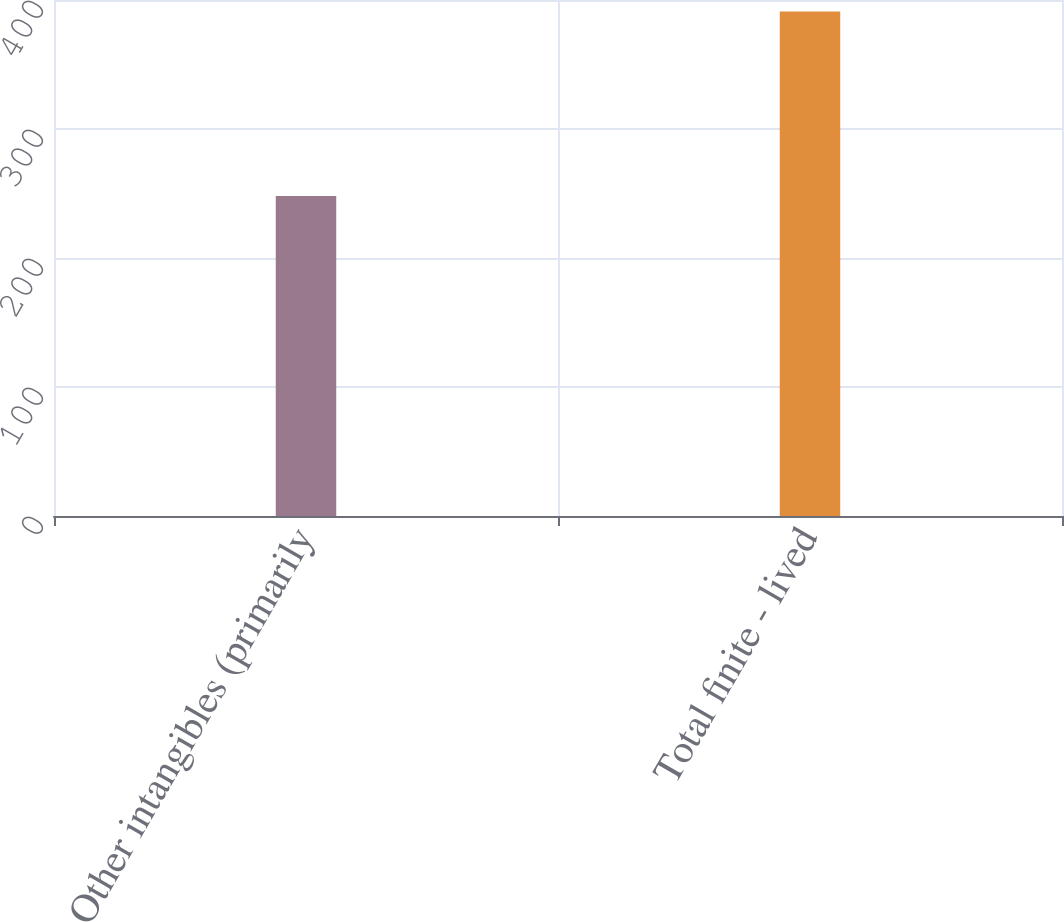<chart> <loc_0><loc_0><loc_500><loc_500><bar_chart><fcel>Other intangibles (primarily<fcel>Total finite - lived<nl><fcel>248<fcel>391<nl></chart> 